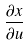<formula> <loc_0><loc_0><loc_500><loc_500>\frac { \partial x } { \partial u }</formula> 